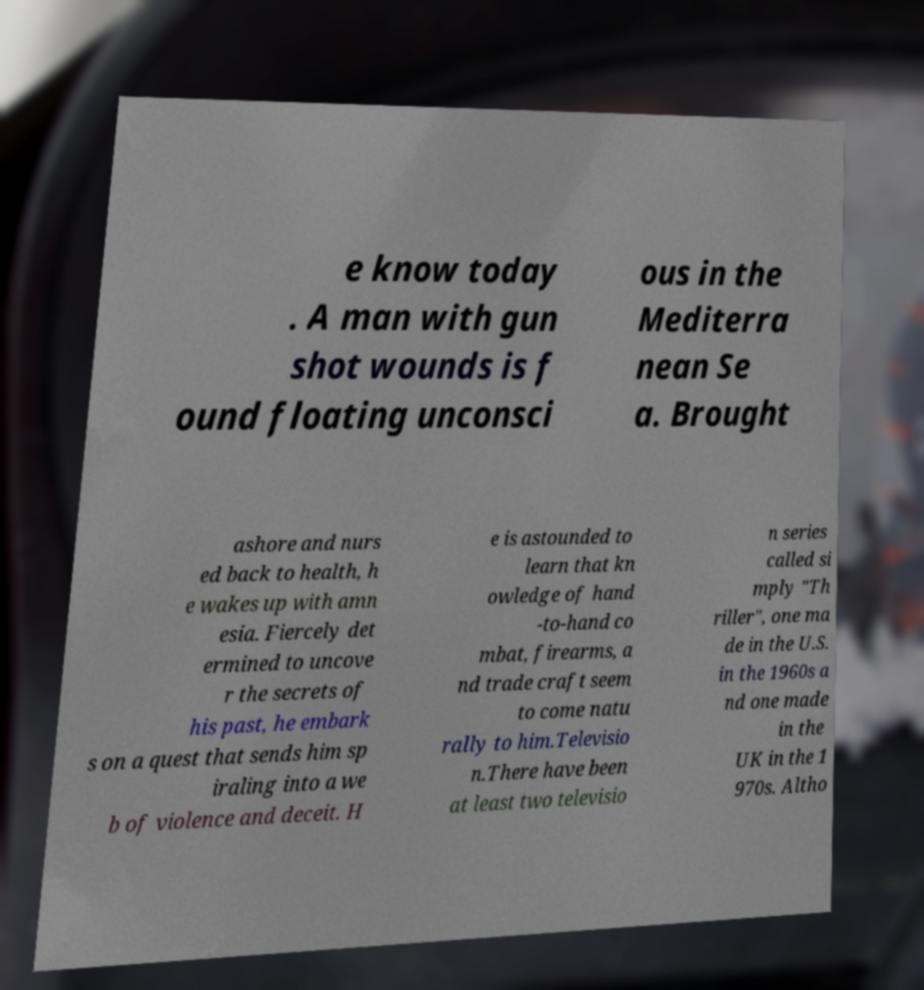Can you accurately transcribe the text from the provided image for me? e know today . A man with gun shot wounds is f ound floating unconsci ous in the Mediterra nean Se a. Brought ashore and nurs ed back to health, h e wakes up with amn esia. Fiercely det ermined to uncove r the secrets of his past, he embark s on a quest that sends him sp iraling into a we b of violence and deceit. H e is astounded to learn that kn owledge of hand -to-hand co mbat, firearms, a nd trade craft seem to come natu rally to him.Televisio n.There have been at least two televisio n series called si mply "Th riller", one ma de in the U.S. in the 1960s a nd one made in the UK in the 1 970s. Altho 